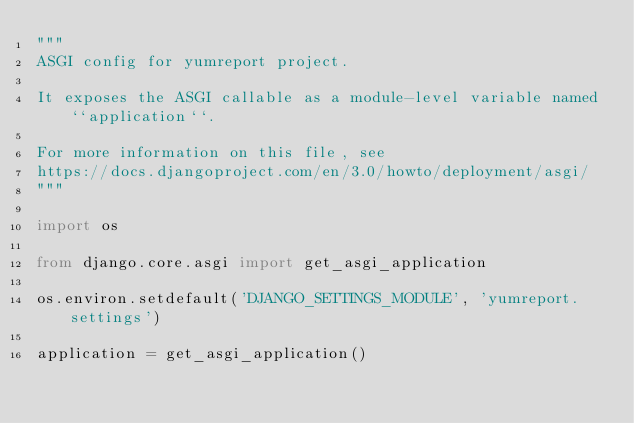<code> <loc_0><loc_0><loc_500><loc_500><_Python_>"""
ASGI config for yumreport project.

It exposes the ASGI callable as a module-level variable named ``application``.

For more information on this file, see
https://docs.djangoproject.com/en/3.0/howto/deployment/asgi/
"""

import os

from django.core.asgi import get_asgi_application

os.environ.setdefault('DJANGO_SETTINGS_MODULE', 'yumreport.settings')

application = get_asgi_application()
</code> 